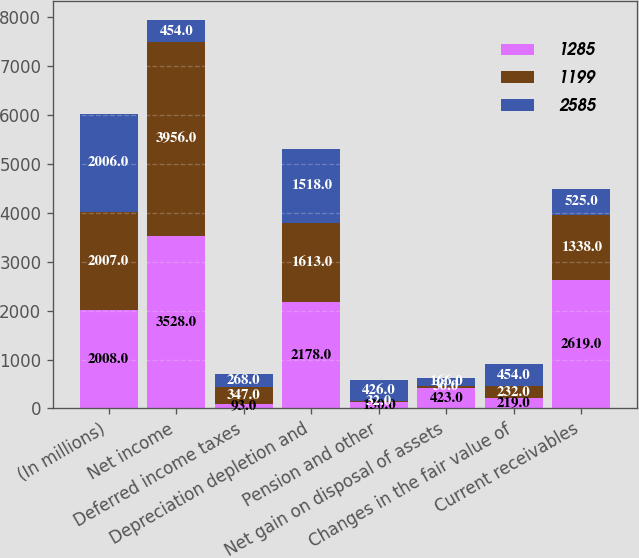Convert chart. <chart><loc_0><loc_0><loc_500><loc_500><stacked_bar_chart><ecel><fcel>(In millions)<fcel>Net income<fcel>Deferred income taxes<fcel>Depreciation depletion and<fcel>Pension and other<fcel>Net gain on disposal of assets<fcel>Changes in the fair value of<fcel>Current receivables<nl><fcel>1285<fcel>2008<fcel>3528<fcel>93<fcel>2178<fcel>130<fcel>423<fcel>219<fcel>2619<nl><fcel>1199<fcel>2007<fcel>3956<fcel>347<fcel>1613<fcel>32<fcel>36<fcel>232<fcel>1338<nl><fcel>2585<fcel>2006<fcel>454<fcel>268<fcel>1518<fcel>426<fcel>166<fcel>454<fcel>525<nl></chart> 